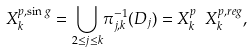Convert formula to latex. <formula><loc_0><loc_0><loc_500><loc_500>X _ { k } ^ { p , \sin g } = \underset { 2 \leq j \leq k } \bigcup \pi _ { j , k } ^ { - 1 } ( D _ { j } ) = X _ { k } ^ { p } \ X _ { k } ^ { p , r e g } ,</formula> 